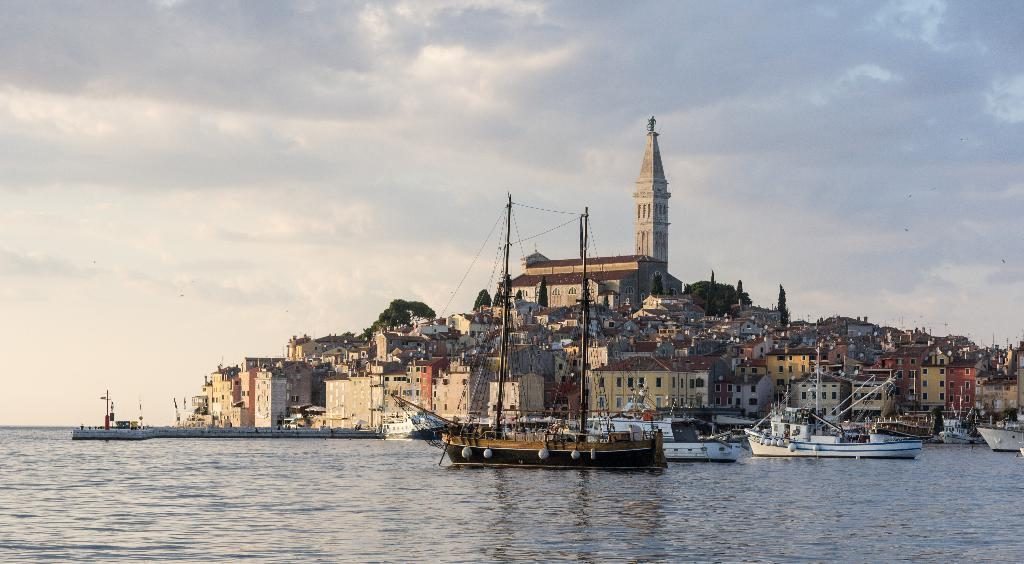What is happening on the water in the image? There are boats sailing on the water in the image. What can be seen on the land in the image? There are buildings, trees, and a tower on the land in the image. What is visible at the top of the image? The sky is visible at the top of the image. Where is the library located in the image? There is no library present in the image. Can you see any icicles hanging from the tower in the image? There are no icicles visible in the image; it is not cold enough for icicles to form. 